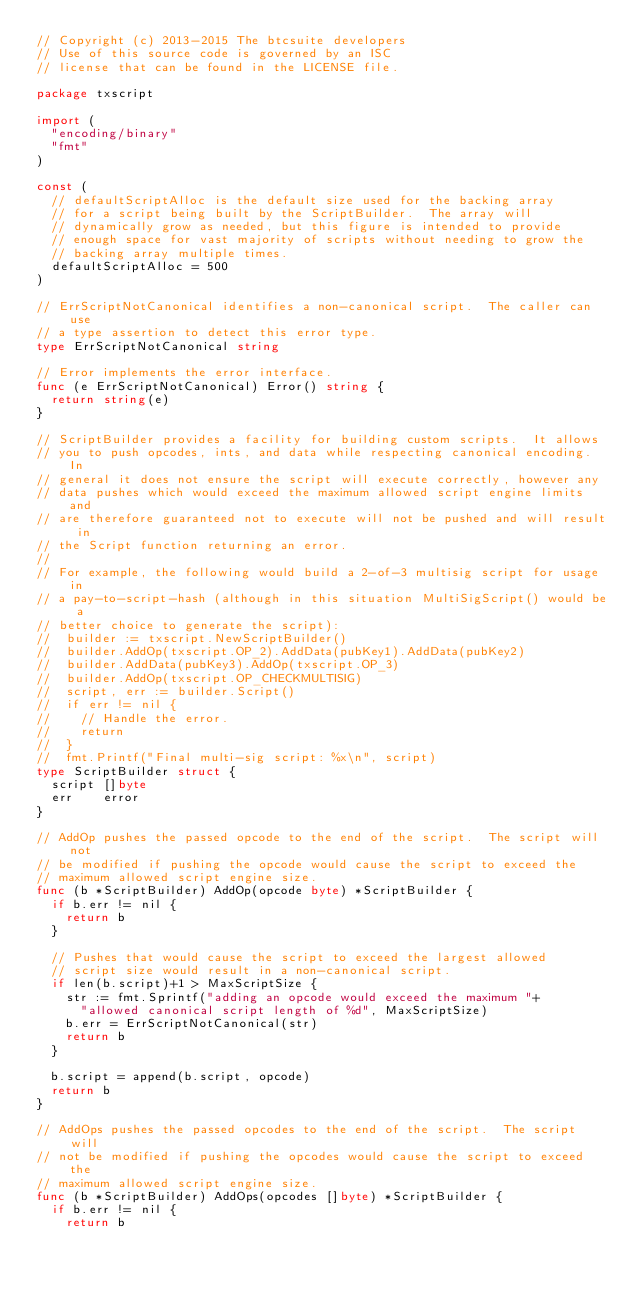<code> <loc_0><loc_0><loc_500><loc_500><_Go_>// Copyright (c) 2013-2015 The btcsuite developers
// Use of this source code is governed by an ISC
// license that can be found in the LICENSE file.

package txscript

import (
	"encoding/binary"
	"fmt"
)

const (
	// defaultScriptAlloc is the default size used for the backing array
	// for a script being built by the ScriptBuilder.  The array will
	// dynamically grow as needed, but this figure is intended to provide
	// enough space for vast majority of scripts without needing to grow the
	// backing array multiple times.
	defaultScriptAlloc = 500
)

// ErrScriptNotCanonical identifies a non-canonical script.  The caller can use
// a type assertion to detect this error type.
type ErrScriptNotCanonical string

// Error implements the error interface.
func (e ErrScriptNotCanonical) Error() string {
	return string(e)
}

// ScriptBuilder provides a facility for building custom scripts.  It allows
// you to push opcodes, ints, and data while respecting canonical encoding.  In
// general it does not ensure the script will execute correctly, however any
// data pushes which would exceed the maximum allowed script engine limits and
// are therefore guaranteed not to execute will not be pushed and will result in
// the Script function returning an error.
//
// For example, the following would build a 2-of-3 multisig script for usage in
// a pay-to-script-hash (although in this situation MultiSigScript() would be a
// better choice to generate the script):
// 	builder := txscript.NewScriptBuilder()
// 	builder.AddOp(txscript.OP_2).AddData(pubKey1).AddData(pubKey2)
// 	builder.AddData(pubKey3).AddOp(txscript.OP_3)
// 	builder.AddOp(txscript.OP_CHECKMULTISIG)
// 	script, err := builder.Script()
// 	if err != nil {
// 		// Handle the error.
// 		return
// 	}
// 	fmt.Printf("Final multi-sig script: %x\n", script)
type ScriptBuilder struct {
	script []byte
	err    error
}

// AddOp pushes the passed opcode to the end of the script.  The script will not
// be modified if pushing the opcode would cause the script to exceed the
// maximum allowed script engine size.
func (b *ScriptBuilder) AddOp(opcode byte) *ScriptBuilder {
	if b.err != nil {
		return b
	}

	// Pushes that would cause the script to exceed the largest allowed
	// script size would result in a non-canonical script.
	if len(b.script)+1 > MaxScriptSize {
		str := fmt.Sprintf("adding an opcode would exceed the maximum "+
			"allowed canonical script length of %d", MaxScriptSize)
		b.err = ErrScriptNotCanonical(str)
		return b
	}

	b.script = append(b.script, opcode)
	return b
}

// AddOps pushes the passed opcodes to the end of the script.  The script will
// not be modified if pushing the opcodes would cause the script to exceed the
// maximum allowed script engine size.
func (b *ScriptBuilder) AddOps(opcodes []byte) *ScriptBuilder {
	if b.err != nil {
		return b</code> 